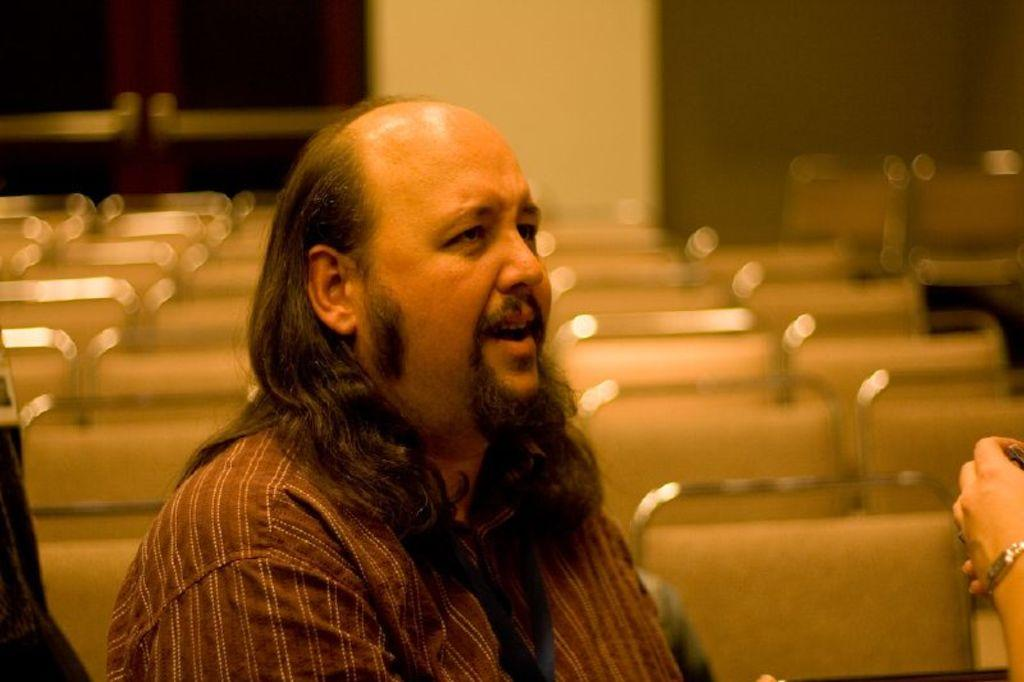What can be observed about the background of the image? The background of the picture is blurred. What type of furniture is present in the image? There are chairs in the image. Can you describe the person in the image? There is a person in the image. What architectural feature can be seen in the image? There is a door in the image. What is the primary structural element in the image? There is a wall in the image. Where is a person's hand located in the image? A person's hand is visible on the right side of the image. What type of can is being held by the person in the image? There is no can present in the image. Can you describe the father in the image? There is no mention of a father or any familial relationship in the image. What type of crown is being worn by the person in the image? There is no crown present in the image. 